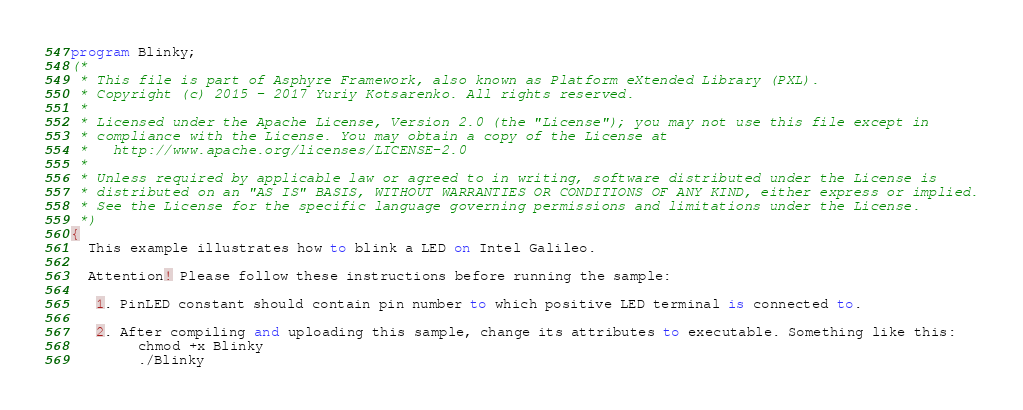Convert code to text. <code><loc_0><loc_0><loc_500><loc_500><_Pascal_>program Blinky;
(*
 * This file is part of Asphyre Framework, also known as Platform eXtended Library (PXL).
 * Copyright (c) 2015 - 2017 Yuriy Kotsarenko. All rights reserved.
 *
 * Licensed under the Apache License, Version 2.0 (the "License"); you may not use this file except in
 * compliance with the License. You may obtain a copy of the License at
 *   http://www.apache.org/licenses/LICENSE-2.0
 *
 * Unless required by applicable law or agreed to in writing, software distributed under the License is
 * distributed on an "AS IS" BASIS, WITHOUT WARRANTIES OR CONDITIONS OF ANY KIND, either express or implied.
 * See the License for the specific language governing permissions and limitations under the License.
 *)
{
  This example illustrates how to blink a LED on Intel Galileo.

  Attention! Please follow these instructions before running the sample:

   1. PinLED constant should contain pin number to which positive LED terminal is connected to.

   2. After compiling and uploading this sample, change its attributes to executable. Something like this:
        chmod +x Blinky
        ./Blinky
</code> 